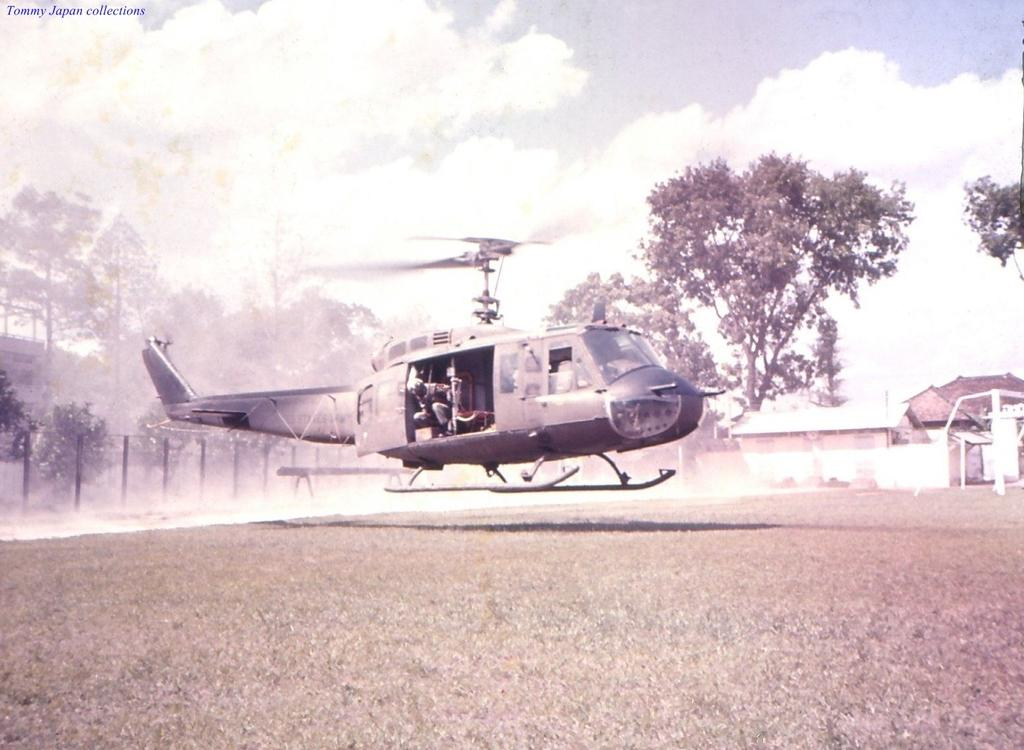What is the main subject of the picture? The main subject of the picture is a helicopter. Who or what is inside the helicopter? There are people seated in the helicopter. What can be seen in the background of the image? There are metal rods, trees, and houses visible in the background of the image. What type of chicken is being cooked by the aunt in the image? There is no aunt or chicken present in the image; it features a helicopter with people inside. What type of army is depicted in the image? There is no army present in the image; it features a helicopter with people inside. 